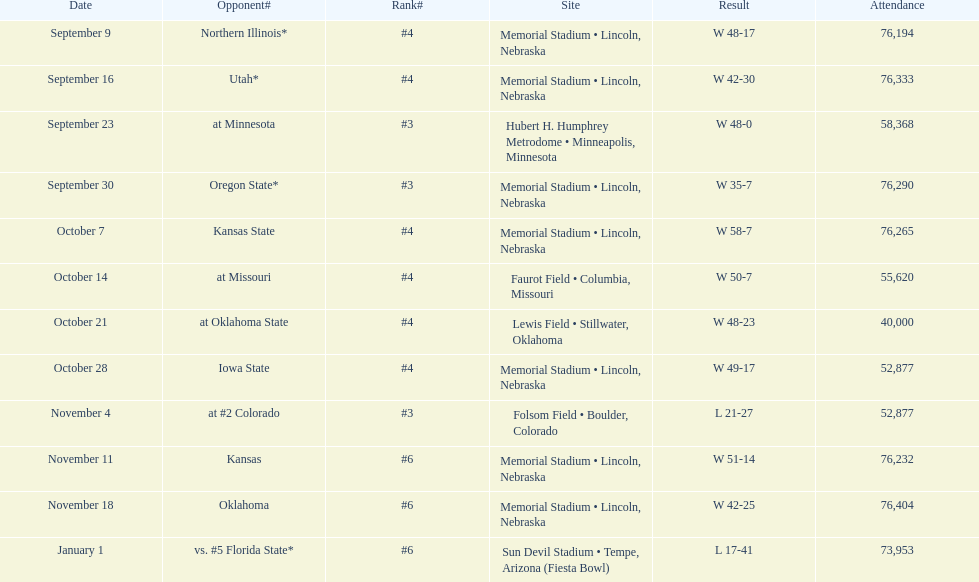Which site comes after lewis field on the list? Memorial Stadium • Lincoln, Nebraska. 